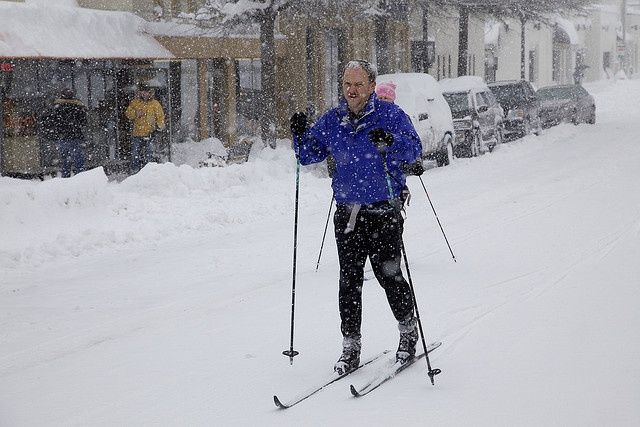Describe the objects in this image and their specific colors. I can see people in darkgray, black, navy, gray, and lightgray tones, car in darkgray, lightgray, and gray tones, car in darkgray, gray, and lightgray tones, truck in darkgray, gray, and black tones, and car in darkgray, gray, and black tones in this image. 